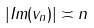<formula> <loc_0><loc_0><loc_500><loc_500>| I m ( v _ { n } ) | \asymp n</formula> 